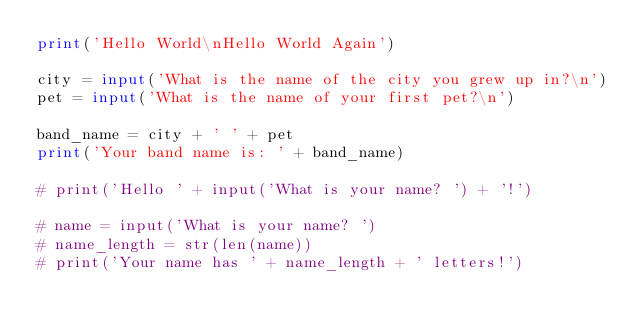<code> <loc_0><loc_0><loc_500><loc_500><_Python_>print('Hello World\nHello World Again')

city = input('What is the name of the city you grew up in?\n')
pet = input('What is the name of your first pet?\n')

band_name = city + ' ' + pet
print('Your band name is: ' + band_name)

# print('Hello ' + input('What is your name? ') + '!')

# name = input('What is your name? ')
# name_length = str(len(name))
# print('Your name has ' + name_length + ' letters!')

</code> 